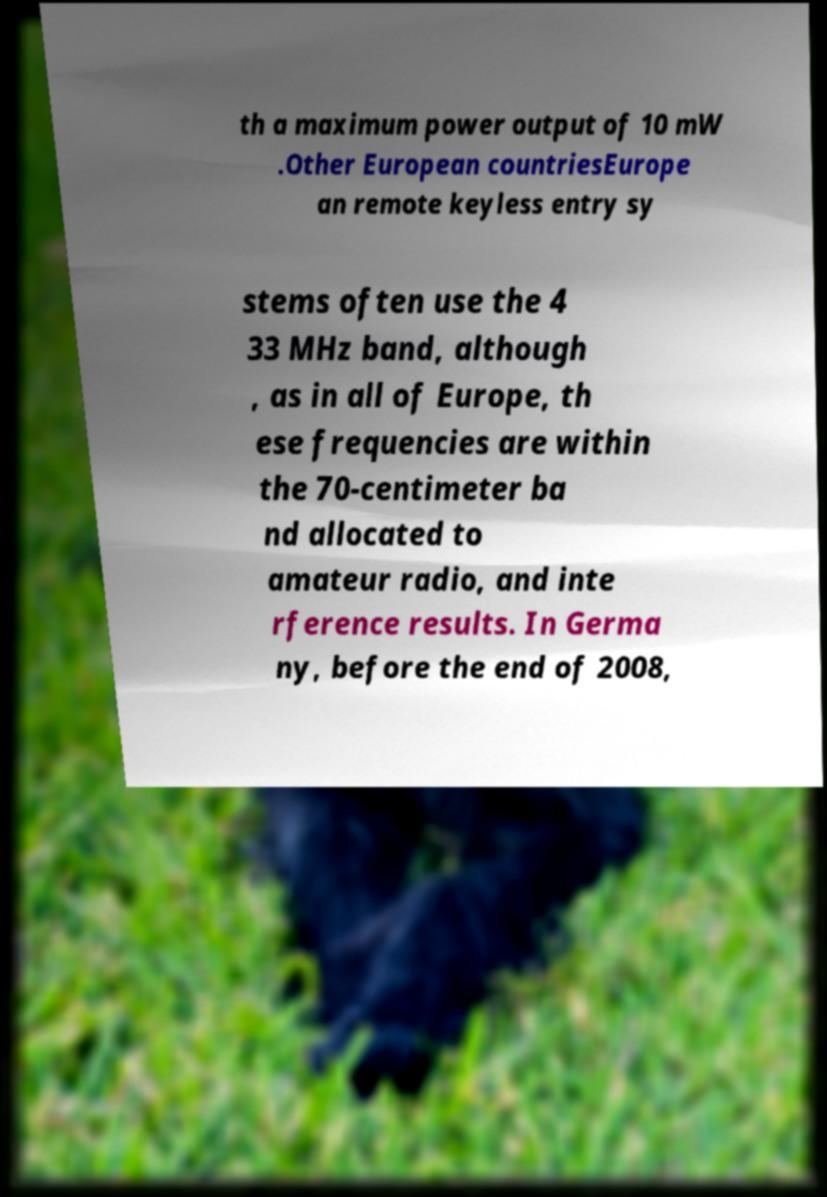Please identify and transcribe the text found in this image. th a maximum power output of 10 mW .Other European countriesEurope an remote keyless entry sy stems often use the 4 33 MHz band, although , as in all of Europe, th ese frequencies are within the 70-centimeter ba nd allocated to amateur radio, and inte rference results. In Germa ny, before the end of 2008, 